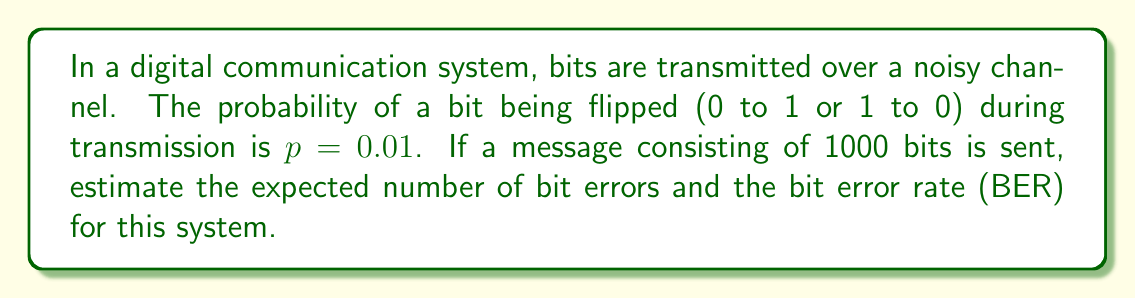Provide a solution to this math problem. Let's approach this step-by-step:

1) First, we need to understand what the bit error rate (BER) represents. BER is the ratio of the number of bit errors to the total number of transmitted bits.

2) In this case, each bit has a probability $p = 0.01$ of being flipped (errored).

3) The number of bit errors in a transmission can be modeled as a binomial distribution, where:
   - $n$ = number of trials (bits transmitted) = 1000
   - $p$ = probability of success (bit error) = 0.01

4) The expected number of errors in a binomial distribution is given by:

   $E(X) = np$

   Where $X$ is the random variable representing the number of errors.

5) Substituting our values:

   $E(X) = 1000 \times 0.01 = 10$

6) Therefore, the expected number of bit errors is 10.

7) To calculate the BER, we divide the expected number of errors by the total number of bits:

   $BER = \frac{E(X)}{n} = \frac{10}{1000} = 0.01$

8) Note that in this case, the BER is equal to $p$, which is generally true for large numbers of transmitted bits.
Answer: Expected number of bit errors: 10; Bit Error Rate (BER): 0.01 